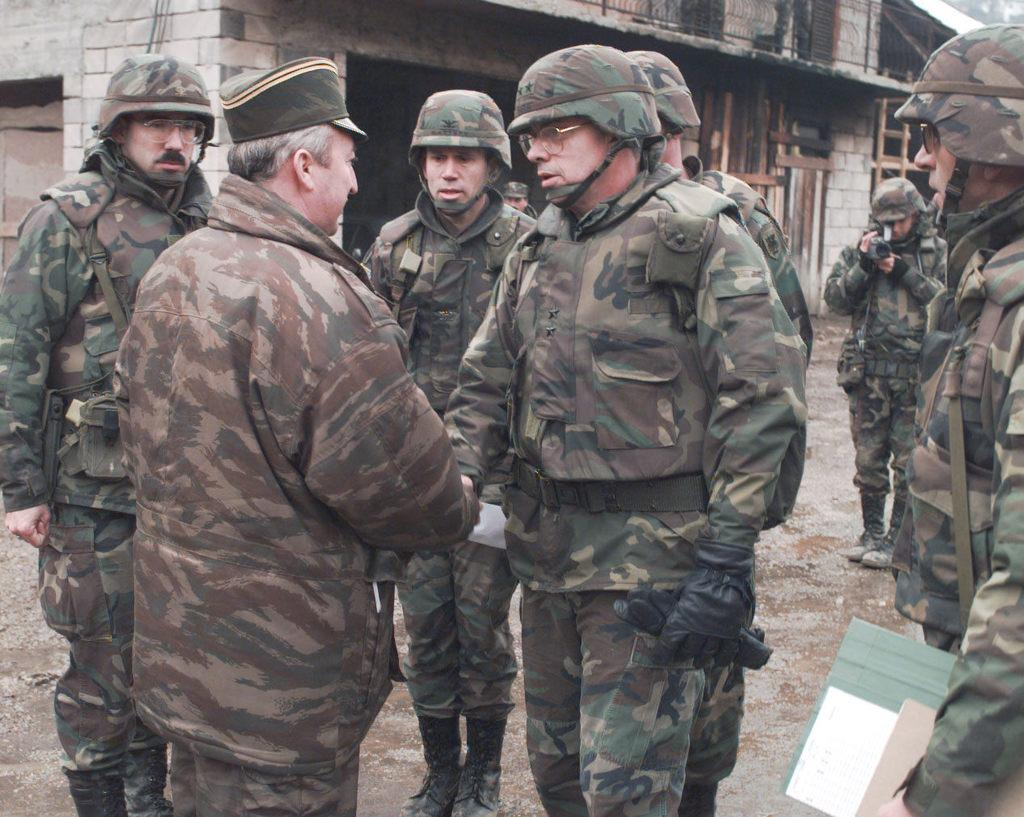How many people are in the image? There is a group of people standing in the image. What is the person on the right side of the image holding? A person is holding some objects on the right side of the image. What can be seen in the background of the image? There is a house visible behind the people. How many ducks are in the room shown in the image? There is no room or ducks present in the image; it features a group of people standing outdoors with a house visible in the background. 